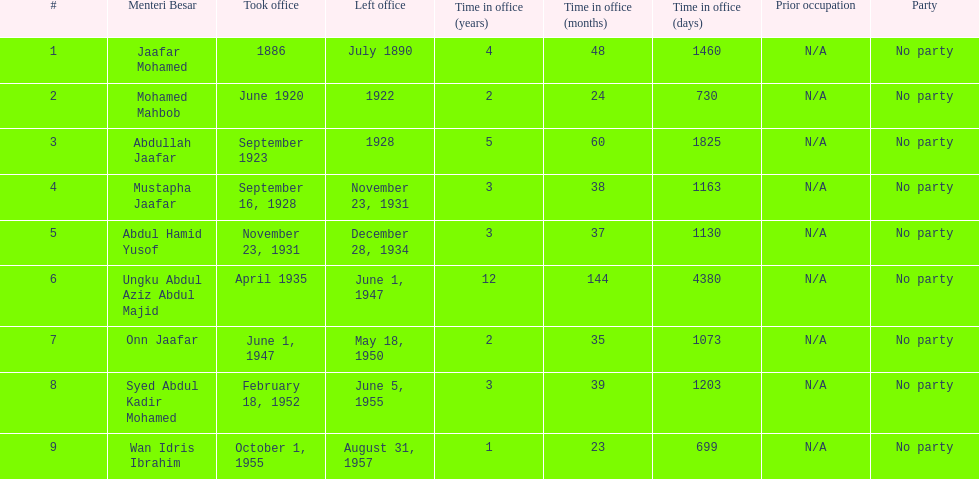Who was in office after mustapha jaafar Abdul Hamid Yusof. 